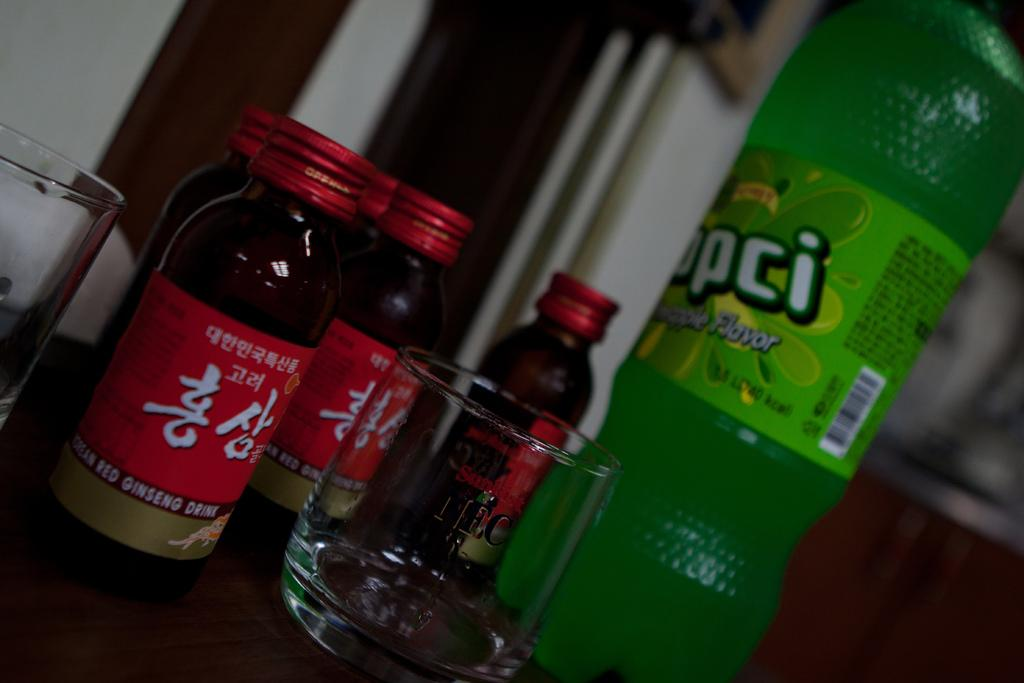<image>
Write a terse but informative summary of the picture. Five bottles of red ginseng drink next to a glass and a green bottle. 